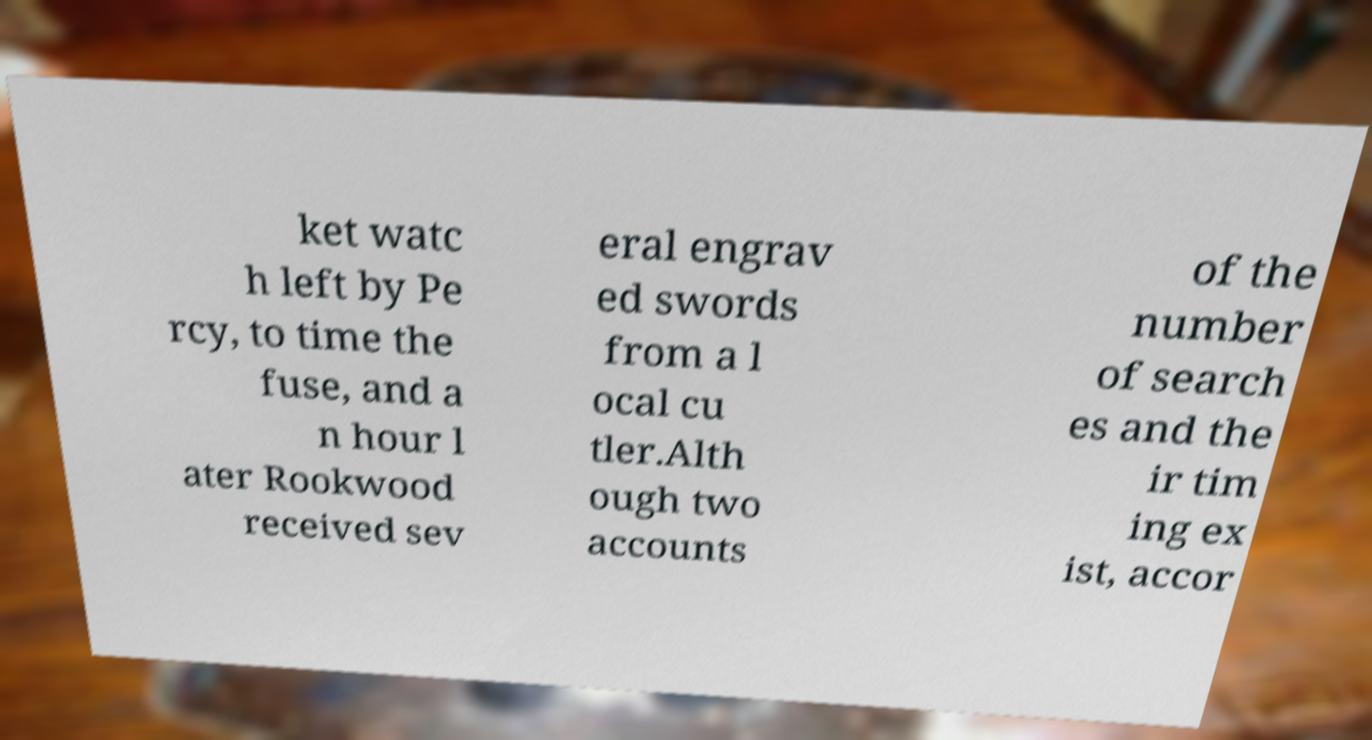Can you accurately transcribe the text from the provided image for me? ket watc h left by Pe rcy, to time the fuse, and a n hour l ater Rookwood received sev eral engrav ed swords from a l ocal cu tler.Alth ough two accounts of the number of search es and the ir tim ing ex ist, accor 